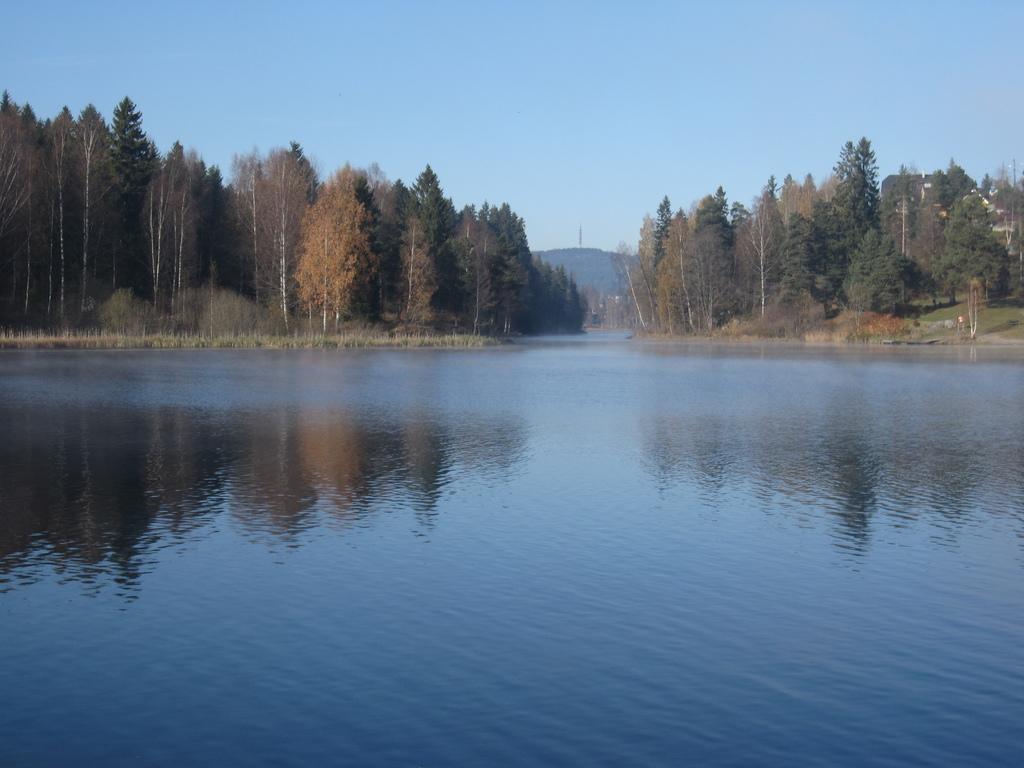Describe this image in one or two sentences. In this image we can see hills, trees, bushes, grass, lake and sky. 